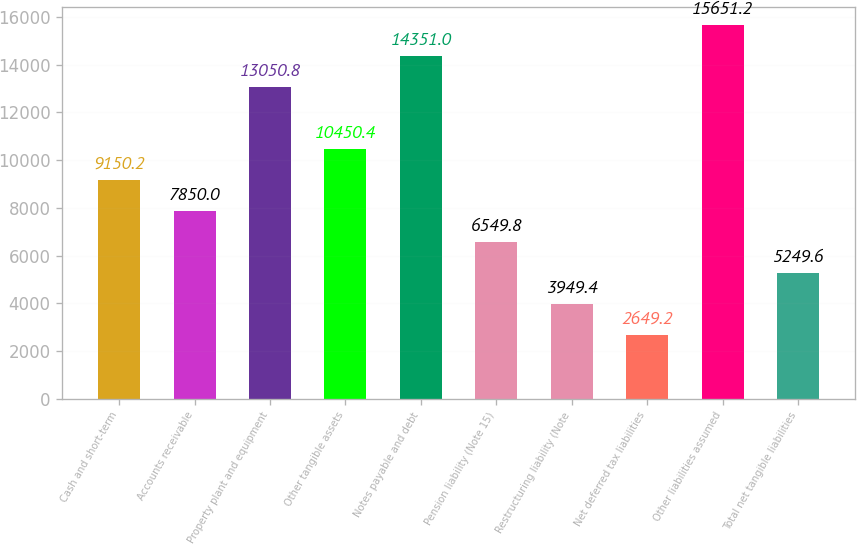Convert chart to OTSL. <chart><loc_0><loc_0><loc_500><loc_500><bar_chart><fcel>Cash and short-term<fcel>Accounts receivable<fcel>Property plant and equipment<fcel>Other tangible assets<fcel>Notes payable and debt<fcel>Pension liability (Note 15)<fcel>Restructuring liability (Note<fcel>Net deferred tax liabilities<fcel>Other liabilities assumed<fcel>Total net tangible liabilities<nl><fcel>9150.2<fcel>7850<fcel>13050.8<fcel>10450.4<fcel>14351<fcel>6549.8<fcel>3949.4<fcel>2649.2<fcel>15651.2<fcel>5249.6<nl></chart> 